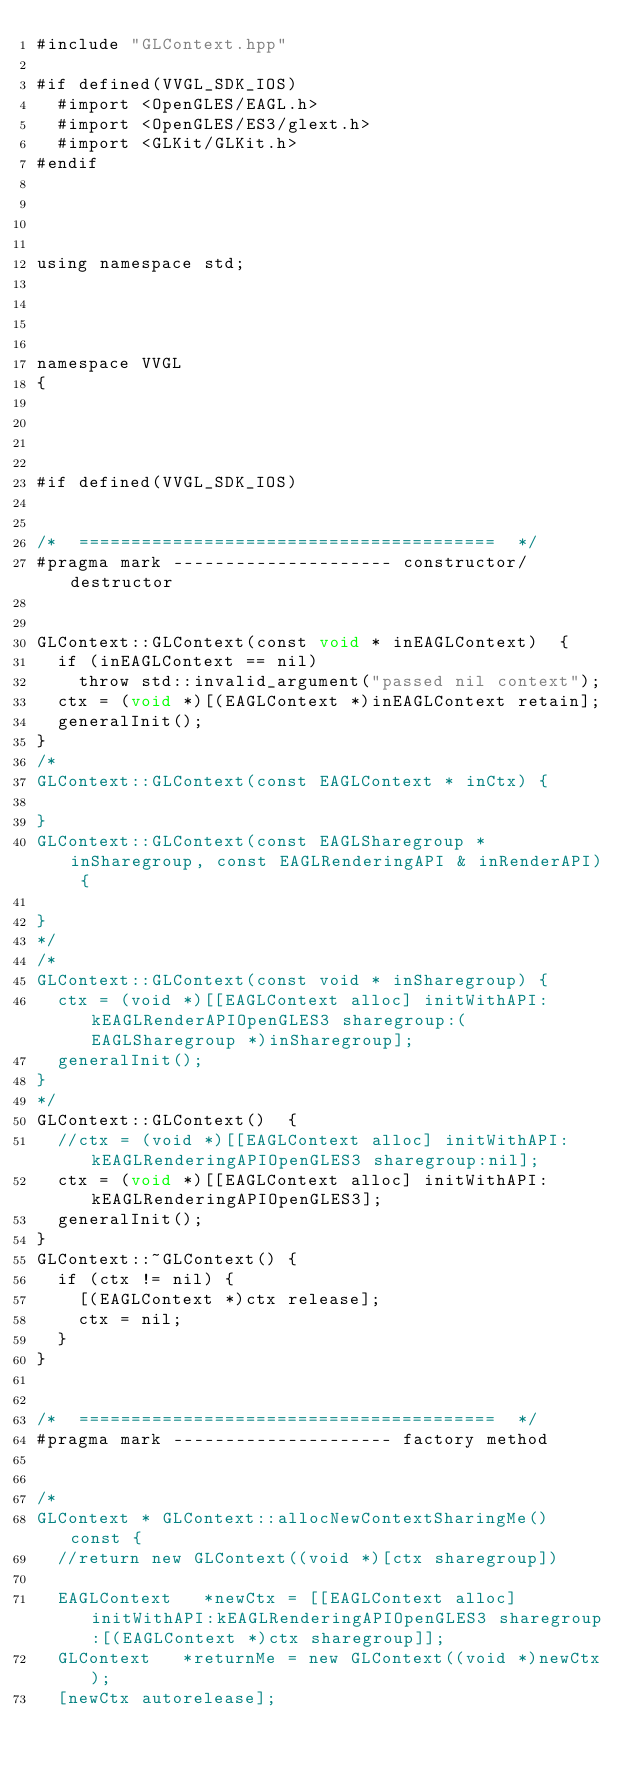Convert code to text. <code><loc_0><loc_0><loc_500><loc_500><_ObjectiveC_>#include "GLContext.hpp"

#if defined(VVGL_SDK_IOS)
	#import <OpenGLES/EAGL.h>
	#import <OpenGLES/ES3/glext.h>
	#import <GLKit/GLKit.h>
#endif




using namespace std;




namespace VVGL
{




#if defined(VVGL_SDK_IOS)


/*	========================================	*/
#pragma mark --------------------- constructor/destructor


GLContext::GLContext(const void * inEAGLContext)	{
	if (inEAGLContext == nil)
		throw std::invalid_argument("passed nil context");
	ctx = (void *)[(EAGLContext *)inEAGLContext retain];
	generalInit();
}
/*
GLContext::GLContext(const EAGLContext * inCtx)	{
	
}
GLContext::GLContext(const EAGLSharegroup * inSharegroup, const EAGLRenderingAPI & inRenderAPI)	{

}
*/
/*
GLContext::GLContext(const void * inSharegroup)	{
	ctx = (void *)[[EAGLContext alloc] initWithAPI:kEAGLRenderAPIOpenGLES3 sharegroup:(EAGLSharegroup *)inSharegroup];
	generalInit();
}
*/
GLContext::GLContext()	{
	//ctx = (void *)[[EAGLContext alloc] initWithAPI:kEAGLRenderingAPIOpenGLES3 sharegroup:nil];
	ctx = (void *)[[EAGLContext alloc] initWithAPI:kEAGLRenderingAPIOpenGLES3];
	generalInit();
}
GLContext::~GLContext()	{
	if (ctx != nil)	{
		[(EAGLContext *)ctx release];
		ctx = nil;
	}
}


/*	========================================	*/
#pragma mark --------------------- factory method


/*
GLContext * GLContext::allocNewContextSharingMe() const	{
	//return new GLContext((void *)[ctx sharegroup])
	
	EAGLContext		*newCtx = [[EAGLContext alloc] initWithAPI:kEAGLRenderingAPIOpenGLES3 sharegroup:[(EAGLContext *)ctx sharegroup]];
	GLContext		*returnMe = new GLContext((void *)newCtx);
	[newCtx autorelease];</code> 